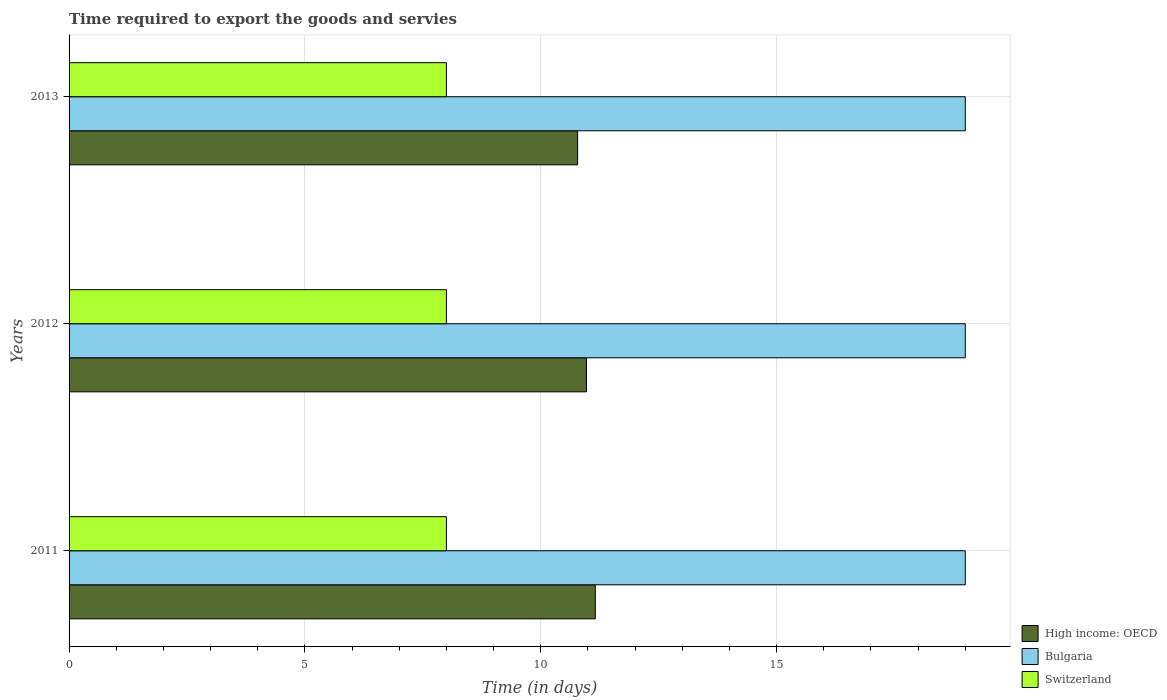How many different coloured bars are there?
Your answer should be compact. 3. How many groups of bars are there?
Keep it short and to the point. 3. What is the label of the 3rd group of bars from the top?
Provide a succinct answer. 2011. What is the number of days required to export the goods and services in Switzerland in 2013?
Ensure brevity in your answer.  8. Across all years, what is the maximum number of days required to export the goods and services in High income: OECD?
Your response must be concise. 11.16. Across all years, what is the minimum number of days required to export the goods and services in Bulgaria?
Ensure brevity in your answer.  19. In which year was the number of days required to export the goods and services in Switzerland minimum?
Make the answer very short. 2011. What is the total number of days required to export the goods and services in Switzerland in the graph?
Provide a succinct answer. 24. What is the difference between the number of days required to export the goods and services in Switzerland in 2011 and the number of days required to export the goods and services in Bulgaria in 2013?
Give a very brief answer. -11. In the year 2013, what is the difference between the number of days required to export the goods and services in High income: OECD and number of days required to export the goods and services in Bulgaria?
Ensure brevity in your answer.  -8.22. In how many years, is the number of days required to export the goods and services in Bulgaria greater than 15 days?
Give a very brief answer. 3. What is the ratio of the number of days required to export the goods and services in High income: OECD in 2011 to that in 2013?
Your answer should be very brief. 1.03. Is the number of days required to export the goods and services in Bulgaria in 2011 less than that in 2013?
Ensure brevity in your answer.  No. What is the difference between the highest and the second highest number of days required to export the goods and services in Bulgaria?
Provide a succinct answer. 0. What is the difference between the highest and the lowest number of days required to export the goods and services in Bulgaria?
Make the answer very short. 0. Is the sum of the number of days required to export the goods and services in Bulgaria in 2012 and 2013 greater than the maximum number of days required to export the goods and services in Switzerland across all years?
Ensure brevity in your answer.  Yes. Is it the case that in every year, the sum of the number of days required to export the goods and services in Bulgaria and number of days required to export the goods and services in High income: OECD is greater than the number of days required to export the goods and services in Switzerland?
Provide a short and direct response. Yes. Are all the bars in the graph horizontal?
Provide a short and direct response. Yes. How many years are there in the graph?
Offer a terse response. 3. What is the difference between two consecutive major ticks on the X-axis?
Your answer should be compact. 5. Are the values on the major ticks of X-axis written in scientific E-notation?
Give a very brief answer. No. Does the graph contain any zero values?
Your response must be concise. No. How are the legend labels stacked?
Keep it short and to the point. Vertical. What is the title of the graph?
Keep it short and to the point. Time required to export the goods and servies. What is the label or title of the X-axis?
Offer a very short reply. Time (in days). What is the Time (in days) in High income: OECD in 2011?
Your answer should be very brief. 11.16. What is the Time (in days) of Bulgaria in 2011?
Your answer should be compact. 19. What is the Time (in days) of High income: OECD in 2012?
Provide a succinct answer. 10.97. What is the Time (in days) of Bulgaria in 2012?
Provide a succinct answer. 19. What is the Time (in days) of High income: OECD in 2013?
Keep it short and to the point. 10.78. What is the Time (in days) of Bulgaria in 2013?
Offer a terse response. 19. Across all years, what is the maximum Time (in days) in High income: OECD?
Provide a succinct answer. 11.16. Across all years, what is the maximum Time (in days) in Bulgaria?
Your response must be concise. 19. Across all years, what is the minimum Time (in days) of High income: OECD?
Your answer should be very brief. 10.78. What is the total Time (in days) in High income: OECD in the graph?
Offer a very short reply. 32.91. What is the total Time (in days) of Switzerland in the graph?
Ensure brevity in your answer.  24. What is the difference between the Time (in days) in High income: OECD in 2011 and that in 2012?
Ensure brevity in your answer.  0.19. What is the difference between the Time (in days) in Bulgaria in 2011 and that in 2012?
Make the answer very short. 0. What is the difference between the Time (in days) in Bulgaria in 2011 and that in 2013?
Make the answer very short. 0. What is the difference between the Time (in days) of Switzerland in 2011 and that in 2013?
Ensure brevity in your answer.  0. What is the difference between the Time (in days) of High income: OECD in 2012 and that in 2013?
Give a very brief answer. 0.19. What is the difference between the Time (in days) in Switzerland in 2012 and that in 2013?
Your answer should be compact. 0. What is the difference between the Time (in days) in High income: OECD in 2011 and the Time (in days) in Bulgaria in 2012?
Make the answer very short. -7.84. What is the difference between the Time (in days) of High income: OECD in 2011 and the Time (in days) of Switzerland in 2012?
Make the answer very short. 3.16. What is the difference between the Time (in days) of Bulgaria in 2011 and the Time (in days) of Switzerland in 2012?
Keep it short and to the point. 11. What is the difference between the Time (in days) of High income: OECD in 2011 and the Time (in days) of Bulgaria in 2013?
Your answer should be compact. -7.84. What is the difference between the Time (in days) of High income: OECD in 2011 and the Time (in days) of Switzerland in 2013?
Your response must be concise. 3.16. What is the difference between the Time (in days) of Bulgaria in 2011 and the Time (in days) of Switzerland in 2013?
Your response must be concise. 11. What is the difference between the Time (in days) of High income: OECD in 2012 and the Time (in days) of Bulgaria in 2013?
Ensure brevity in your answer.  -8.03. What is the difference between the Time (in days) of High income: OECD in 2012 and the Time (in days) of Switzerland in 2013?
Offer a very short reply. 2.97. What is the average Time (in days) in High income: OECD per year?
Offer a very short reply. 10.97. What is the average Time (in days) of Switzerland per year?
Your answer should be compact. 8. In the year 2011, what is the difference between the Time (in days) in High income: OECD and Time (in days) in Bulgaria?
Keep it short and to the point. -7.84. In the year 2011, what is the difference between the Time (in days) of High income: OECD and Time (in days) of Switzerland?
Provide a succinct answer. 3.16. In the year 2012, what is the difference between the Time (in days) of High income: OECD and Time (in days) of Bulgaria?
Your response must be concise. -8.03. In the year 2012, what is the difference between the Time (in days) in High income: OECD and Time (in days) in Switzerland?
Provide a short and direct response. 2.97. In the year 2012, what is the difference between the Time (in days) of Bulgaria and Time (in days) of Switzerland?
Offer a very short reply. 11. In the year 2013, what is the difference between the Time (in days) of High income: OECD and Time (in days) of Bulgaria?
Keep it short and to the point. -8.22. In the year 2013, what is the difference between the Time (in days) of High income: OECD and Time (in days) of Switzerland?
Offer a very short reply. 2.78. In the year 2013, what is the difference between the Time (in days) in Bulgaria and Time (in days) in Switzerland?
Make the answer very short. 11. What is the ratio of the Time (in days) in High income: OECD in 2011 to that in 2012?
Ensure brevity in your answer.  1.02. What is the ratio of the Time (in days) in Bulgaria in 2011 to that in 2012?
Provide a succinct answer. 1. What is the ratio of the Time (in days) in Switzerland in 2011 to that in 2012?
Give a very brief answer. 1. What is the ratio of the Time (in days) of High income: OECD in 2011 to that in 2013?
Provide a short and direct response. 1.03. What is the ratio of the Time (in days) in Bulgaria in 2011 to that in 2013?
Offer a terse response. 1. What is the ratio of the Time (in days) in High income: OECD in 2012 to that in 2013?
Provide a short and direct response. 1.02. What is the ratio of the Time (in days) of Bulgaria in 2012 to that in 2013?
Your answer should be compact. 1. What is the difference between the highest and the second highest Time (in days) of High income: OECD?
Offer a very short reply. 0.19. What is the difference between the highest and the second highest Time (in days) in Bulgaria?
Provide a short and direct response. 0. 